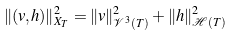<formula> <loc_0><loc_0><loc_500><loc_500>\| ( v , h ) \| ^ { 2 } _ { X _ { T } } = \| v \| ^ { 2 } _ { { \mathcal { V } } ^ { 3 } ( T ) } + \| h \| ^ { 2 } _ { { \mathcal { H } } ( T ) }</formula> 